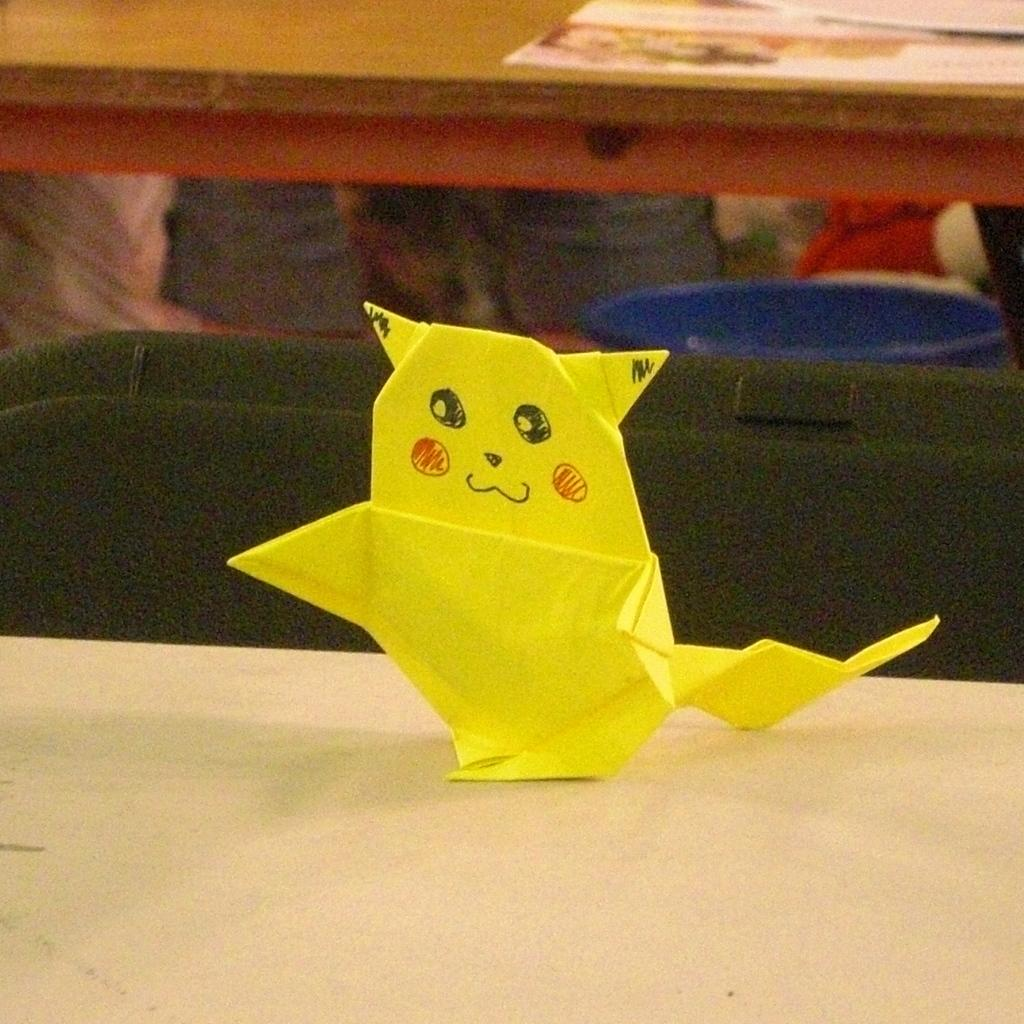What is on the table in the image? There is paper craft on the table. What can be seen in the background of the image? There is paper and other objects in the background of the image. What type of thread is being used by the arm in the image? There is no arm or thread present in the image; it features paper craft on a table and objects in the background. 